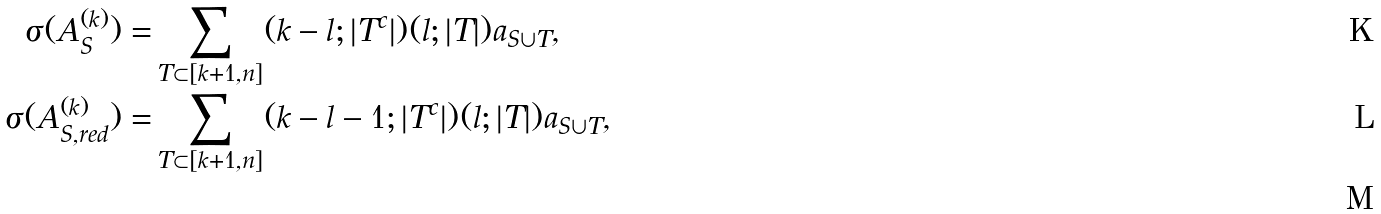<formula> <loc_0><loc_0><loc_500><loc_500>\sigma ( A _ { S } ^ { ( k ) } ) = & \sum _ { T \subset [ k + 1 , n ] } ( k - l ; | T ^ { c } | ) ( l ; | T | ) a _ { S \cup T } , \\ \sigma ( A _ { S , r e d } ^ { ( k ) } ) = & \sum _ { T \subset [ k + 1 , n ] } ( k - l - 1 ; | T ^ { c } | ) ( l ; | T | ) a _ { S \cup T } , \\</formula> 